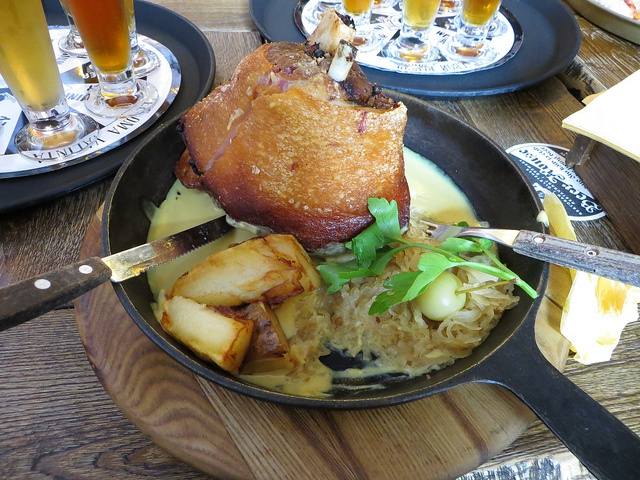Describe the objects in this image and their specific colors. I can see dining table in gray, black, white, olive, and tan tones, cup in olive, lavender, and tan tones, knife in olive, black, and gray tones, cup in olive, maroon, lightgray, and darkgray tones, and fork in olive, darkgray, lightgray, and lightblue tones in this image. 